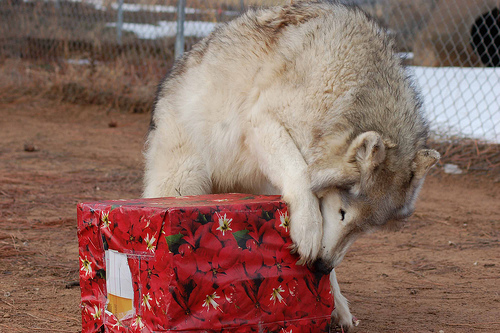<image>
Is there a present under the wolf? Yes. The present is positioned underneath the wolf, with the wolf above it in the vertical space. 